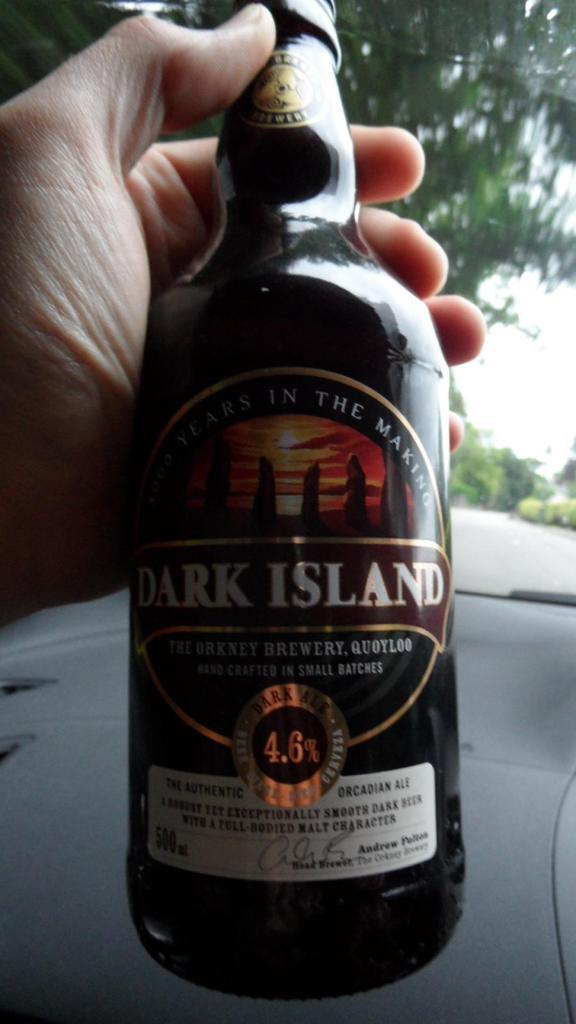<image>
Present a compact description of the photo's key features. A black bottle of Dark Island Orcadian Ale 